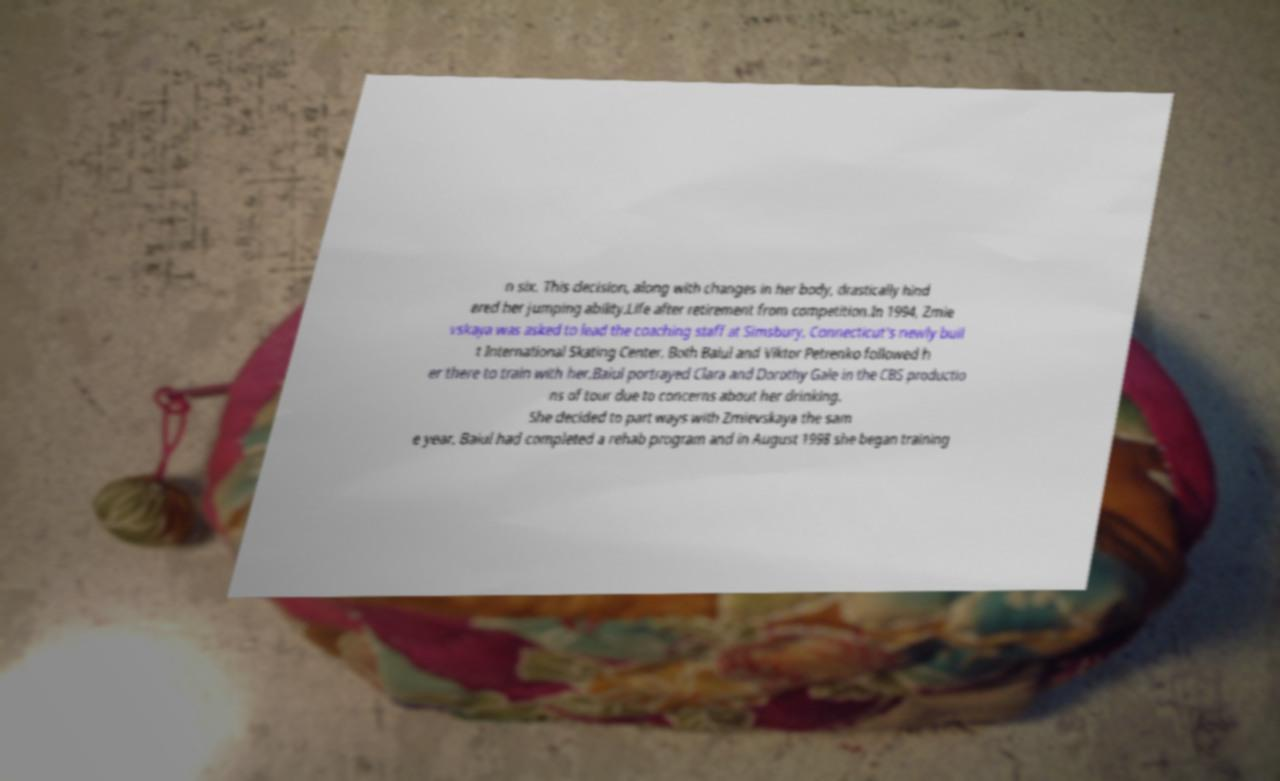There's text embedded in this image that I need extracted. Can you transcribe it verbatim? n six. This decision, along with changes in her body, drastically hind ered her jumping ability.Life after retirement from competition.In 1994, Zmie vskaya was asked to lead the coaching staff at Simsbury, Connecticut's newly buil t International Skating Center. Both Baiul and Viktor Petrenko followed h er there to train with her.Baiul portrayed Clara and Dorothy Gale in the CBS productio ns of tour due to concerns about her drinking. She decided to part ways with Zmievskaya the sam e year. Baiul had completed a rehab program and in August 1998 she began training 